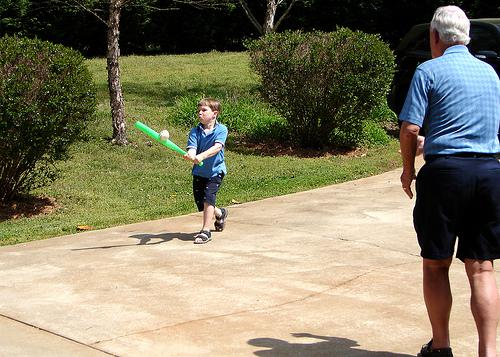Question: what color is the ground?
Choices:
A. Tan.
B. Grey.
C. Black.
D. Brown.
Answer with the letter. Answer: A Question: what color shirts are the people wearing?
Choices:
A. Red.
B. Blue.
C. Pink.
D. Purple.
Answer with the letter. Answer: B Question: what is the bat made of?
Choices:
A. Plastic.
B. Wood.
C. Aluminun.
D. Rubber.
Answer with the letter. Answer: A Question: what is the ground made of?
Choices:
A. Brick.
B. Stone.
C. Dirt.
D. Clay.
Answer with the letter. Answer: B 